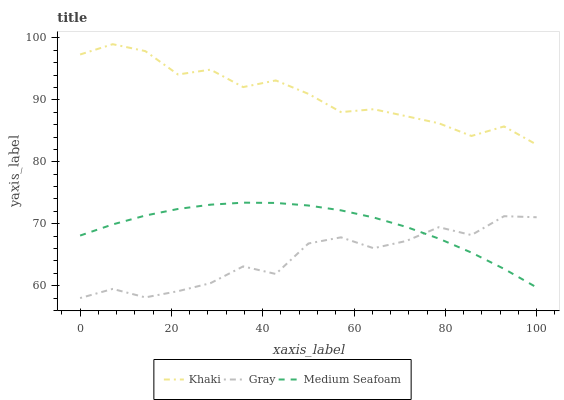Does Gray have the minimum area under the curve?
Answer yes or no. Yes. Does Khaki have the maximum area under the curve?
Answer yes or no. Yes. Does Medium Seafoam have the minimum area under the curve?
Answer yes or no. No. Does Medium Seafoam have the maximum area under the curve?
Answer yes or no. No. Is Medium Seafoam the smoothest?
Answer yes or no. Yes. Is Gray the roughest?
Answer yes or no. Yes. Is Khaki the smoothest?
Answer yes or no. No. Is Khaki the roughest?
Answer yes or no. No. Does Gray have the lowest value?
Answer yes or no. Yes. Does Medium Seafoam have the lowest value?
Answer yes or no. No. Does Khaki have the highest value?
Answer yes or no. Yes. Does Medium Seafoam have the highest value?
Answer yes or no. No. Is Gray less than Khaki?
Answer yes or no. Yes. Is Khaki greater than Medium Seafoam?
Answer yes or no. Yes. Does Medium Seafoam intersect Gray?
Answer yes or no. Yes. Is Medium Seafoam less than Gray?
Answer yes or no. No. Is Medium Seafoam greater than Gray?
Answer yes or no. No. Does Gray intersect Khaki?
Answer yes or no. No. 